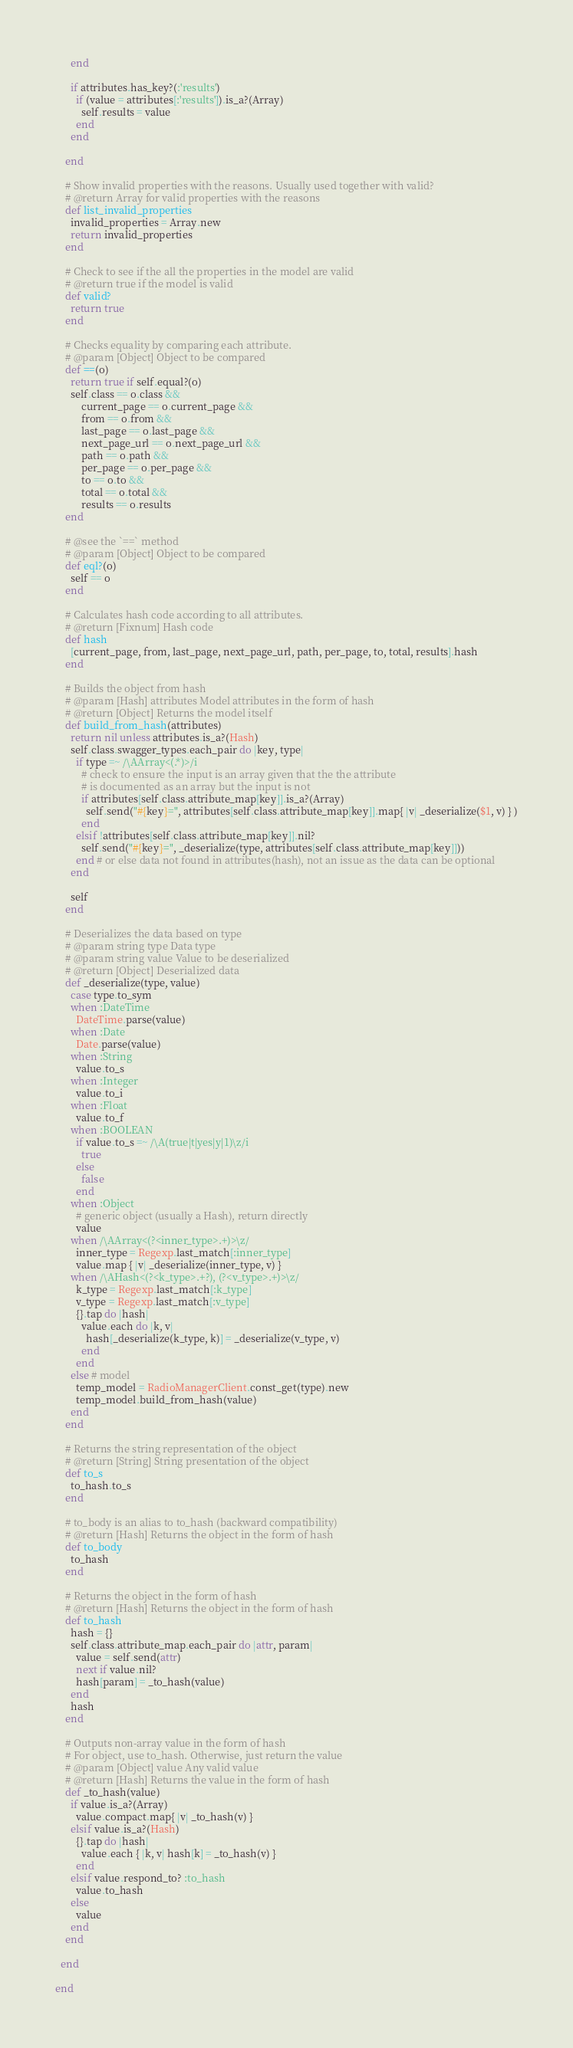Convert code to text. <code><loc_0><loc_0><loc_500><loc_500><_Ruby_>      end

      if attributes.has_key?(:'results')
        if (value = attributes[:'results']).is_a?(Array)
          self.results = value
        end
      end

    end

    # Show invalid properties with the reasons. Usually used together with valid?
    # @return Array for valid properties with the reasons
    def list_invalid_properties
      invalid_properties = Array.new
      return invalid_properties
    end

    # Check to see if the all the properties in the model are valid
    # @return true if the model is valid
    def valid?
      return true
    end

    # Checks equality by comparing each attribute.
    # @param [Object] Object to be compared
    def ==(o)
      return true if self.equal?(o)
      self.class == o.class &&
          current_page == o.current_page &&
          from == o.from &&
          last_page == o.last_page &&
          next_page_url == o.next_page_url &&
          path == o.path &&
          per_page == o.per_page &&
          to == o.to &&
          total == o.total &&
          results == o.results
    end

    # @see the `==` method
    # @param [Object] Object to be compared
    def eql?(o)
      self == o
    end

    # Calculates hash code according to all attributes.
    # @return [Fixnum] Hash code
    def hash
      [current_page, from, last_page, next_page_url, path, per_page, to, total, results].hash
    end

    # Builds the object from hash
    # @param [Hash] attributes Model attributes in the form of hash
    # @return [Object] Returns the model itself
    def build_from_hash(attributes)
      return nil unless attributes.is_a?(Hash)
      self.class.swagger_types.each_pair do |key, type|
        if type =~ /\AArray<(.*)>/i
          # check to ensure the input is an array given that the the attribute
          # is documented as an array but the input is not
          if attributes[self.class.attribute_map[key]].is_a?(Array)
            self.send("#{key}=", attributes[self.class.attribute_map[key]].map{ |v| _deserialize($1, v) } )
          end
        elsif !attributes[self.class.attribute_map[key]].nil?
          self.send("#{key}=", _deserialize(type, attributes[self.class.attribute_map[key]]))
        end # or else data not found in attributes(hash), not an issue as the data can be optional
      end

      self
    end

    # Deserializes the data based on type
    # @param string type Data type
    # @param string value Value to be deserialized
    # @return [Object] Deserialized data
    def _deserialize(type, value)
      case type.to_sym
      when :DateTime
        DateTime.parse(value)
      when :Date
        Date.parse(value)
      when :String
        value.to_s
      when :Integer
        value.to_i
      when :Float
        value.to_f
      when :BOOLEAN
        if value.to_s =~ /\A(true|t|yes|y|1)\z/i
          true
        else
          false
        end
      when :Object
        # generic object (usually a Hash), return directly
        value
      when /\AArray<(?<inner_type>.+)>\z/
        inner_type = Regexp.last_match[:inner_type]
        value.map { |v| _deserialize(inner_type, v) }
      when /\AHash<(?<k_type>.+?), (?<v_type>.+)>\z/
        k_type = Regexp.last_match[:k_type]
        v_type = Regexp.last_match[:v_type]
        {}.tap do |hash|
          value.each do |k, v|
            hash[_deserialize(k_type, k)] = _deserialize(v_type, v)
          end
        end
      else # model
        temp_model = RadioManagerClient.const_get(type).new
        temp_model.build_from_hash(value)
      end
    end

    # Returns the string representation of the object
    # @return [String] String presentation of the object
    def to_s
      to_hash.to_s
    end

    # to_body is an alias to to_hash (backward compatibility)
    # @return [Hash] Returns the object in the form of hash
    def to_body
      to_hash
    end

    # Returns the object in the form of hash
    # @return [Hash] Returns the object in the form of hash
    def to_hash
      hash = {}
      self.class.attribute_map.each_pair do |attr, param|
        value = self.send(attr)
        next if value.nil?
        hash[param] = _to_hash(value)
      end
      hash
    end

    # Outputs non-array value in the form of hash
    # For object, use to_hash. Otherwise, just return the value
    # @param [Object] value Any valid value
    # @return [Hash] Returns the value in the form of hash
    def _to_hash(value)
      if value.is_a?(Array)
        value.compact.map{ |v| _to_hash(v) }
      elsif value.is_a?(Hash)
        {}.tap do |hash|
          value.each { |k, v| hash[k] = _to_hash(v) }
        end
      elsif value.respond_to? :to_hash
        value.to_hash
      else
        value
      end
    end

  end

end
</code> 